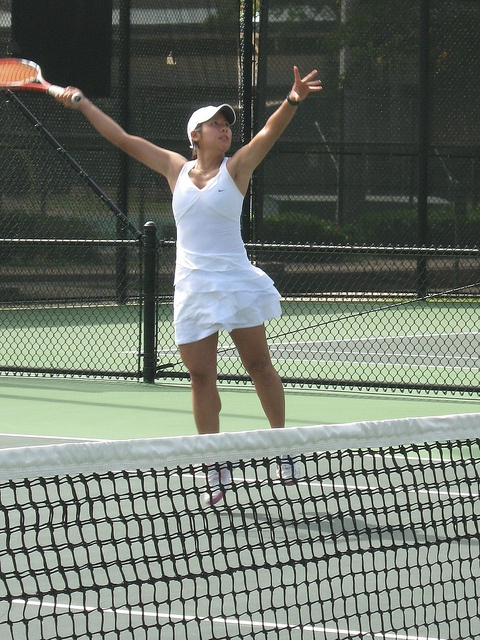Describe the objects in this image and their specific colors. I can see people in black, darkgray, gray, and lavender tones and tennis racket in black, tan, white, and salmon tones in this image. 